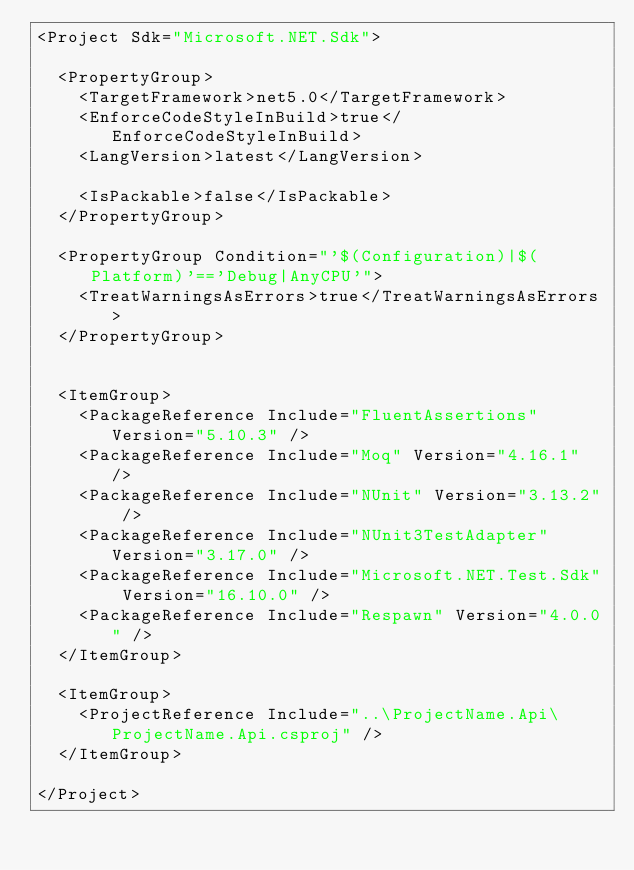Convert code to text. <code><loc_0><loc_0><loc_500><loc_500><_XML_><Project Sdk="Microsoft.NET.Sdk">

  <PropertyGroup>
    <TargetFramework>net5.0</TargetFramework>
    <EnforceCodeStyleInBuild>true</EnforceCodeStyleInBuild>
    <LangVersion>latest</LangVersion>

    <IsPackable>false</IsPackable>
  </PropertyGroup>

  <PropertyGroup Condition="'$(Configuration)|$(Platform)'=='Debug|AnyCPU'">
    <TreatWarningsAsErrors>true</TreatWarningsAsErrors>
  </PropertyGroup>


  <ItemGroup>
    <PackageReference Include="FluentAssertions" Version="5.10.3" />
    <PackageReference Include="Moq" Version="4.16.1" />
    <PackageReference Include="NUnit" Version="3.13.2" />
    <PackageReference Include="NUnit3TestAdapter" Version="3.17.0" />
    <PackageReference Include="Microsoft.NET.Test.Sdk" Version="16.10.0" />
    <PackageReference Include="Respawn" Version="4.0.0" />
  </ItemGroup>

  <ItemGroup>
    <ProjectReference Include="..\ProjectName.Api\ProjectName.Api.csproj" />
  </ItemGroup>

</Project>
</code> 